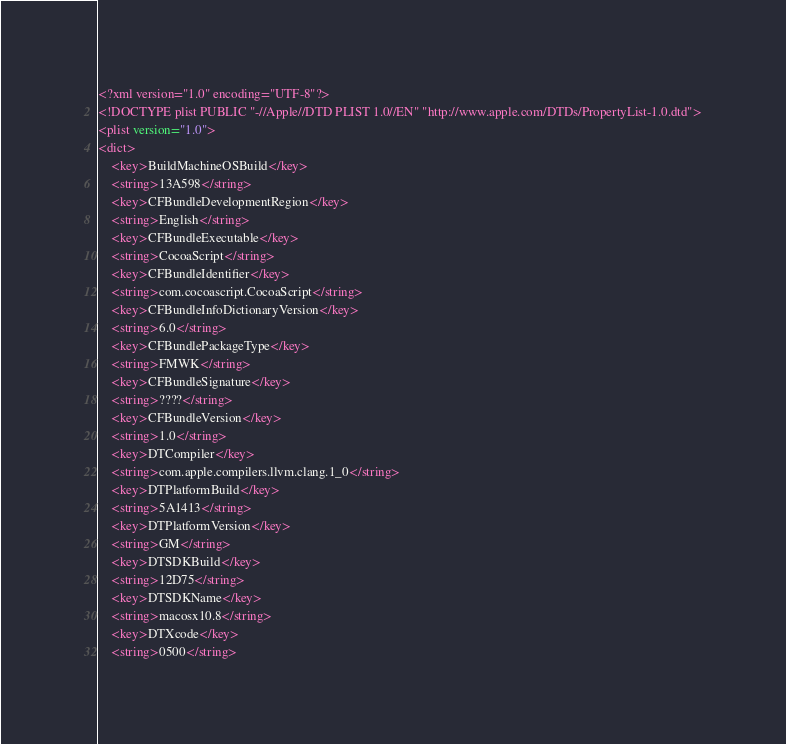Convert code to text. <code><loc_0><loc_0><loc_500><loc_500><_XML_><?xml version="1.0" encoding="UTF-8"?>
<!DOCTYPE plist PUBLIC "-//Apple//DTD PLIST 1.0//EN" "http://www.apple.com/DTDs/PropertyList-1.0.dtd">
<plist version="1.0">
<dict>
	<key>BuildMachineOSBuild</key>
	<string>13A598</string>
	<key>CFBundleDevelopmentRegion</key>
	<string>English</string>
	<key>CFBundleExecutable</key>
	<string>CocoaScript</string>
	<key>CFBundleIdentifier</key>
	<string>com.cocoascript.CocoaScript</string>
	<key>CFBundleInfoDictionaryVersion</key>
	<string>6.0</string>
	<key>CFBundlePackageType</key>
	<string>FMWK</string>
	<key>CFBundleSignature</key>
	<string>????</string>
	<key>CFBundleVersion</key>
	<string>1.0</string>
	<key>DTCompiler</key>
	<string>com.apple.compilers.llvm.clang.1_0</string>
	<key>DTPlatformBuild</key>
	<string>5A1413</string>
	<key>DTPlatformVersion</key>
	<string>GM</string>
	<key>DTSDKBuild</key>
	<string>12D75</string>
	<key>DTSDKName</key>
	<string>macosx10.8</string>
	<key>DTXcode</key>
	<string>0500</string></code> 